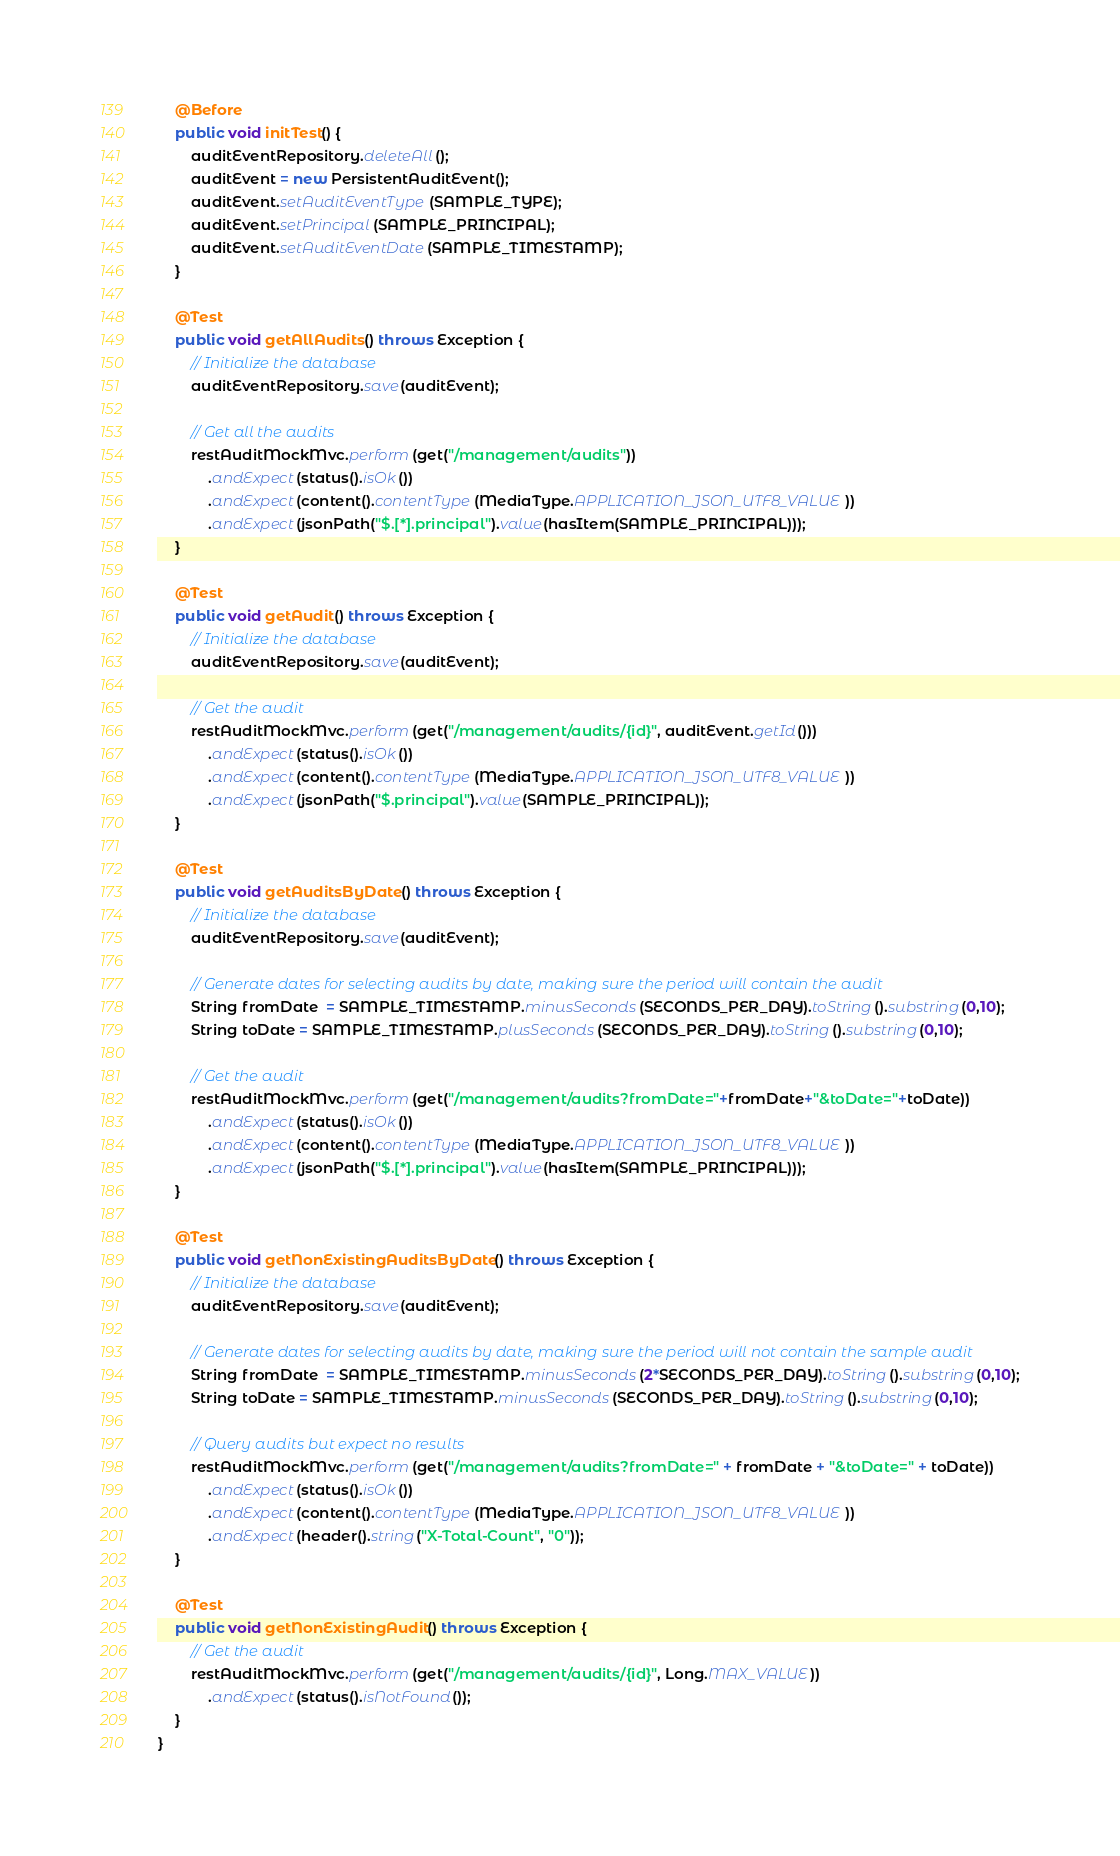Convert code to text. <code><loc_0><loc_0><loc_500><loc_500><_Java_>    @Before
    public void initTest() {
        auditEventRepository.deleteAll();
        auditEvent = new PersistentAuditEvent();
        auditEvent.setAuditEventType(SAMPLE_TYPE);
        auditEvent.setPrincipal(SAMPLE_PRINCIPAL);
        auditEvent.setAuditEventDate(SAMPLE_TIMESTAMP);
    }

    @Test
    public void getAllAudits() throws Exception {
        // Initialize the database
        auditEventRepository.save(auditEvent);

        // Get all the audits
        restAuditMockMvc.perform(get("/management/audits"))
            .andExpect(status().isOk())
            .andExpect(content().contentType(MediaType.APPLICATION_JSON_UTF8_VALUE))
            .andExpect(jsonPath("$.[*].principal").value(hasItem(SAMPLE_PRINCIPAL)));
    }

    @Test
    public void getAudit() throws Exception {
        // Initialize the database
        auditEventRepository.save(auditEvent);

        // Get the audit
        restAuditMockMvc.perform(get("/management/audits/{id}", auditEvent.getId()))
            .andExpect(status().isOk())
            .andExpect(content().contentType(MediaType.APPLICATION_JSON_UTF8_VALUE))
            .andExpect(jsonPath("$.principal").value(SAMPLE_PRINCIPAL));
    }

    @Test
    public void getAuditsByDate() throws Exception {
        // Initialize the database
        auditEventRepository.save(auditEvent);

        // Generate dates for selecting audits by date, making sure the period will contain the audit
        String fromDate  = SAMPLE_TIMESTAMP.minusSeconds(SECONDS_PER_DAY).toString().substring(0,10);
        String toDate = SAMPLE_TIMESTAMP.plusSeconds(SECONDS_PER_DAY).toString().substring(0,10);

        // Get the audit
        restAuditMockMvc.perform(get("/management/audits?fromDate="+fromDate+"&toDate="+toDate))
            .andExpect(status().isOk())
            .andExpect(content().contentType(MediaType.APPLICATION_JSON_UTF8_VALUE))
            .andExpect(jsonPath("$.[*].principal").value(hasItem(SAMPLE_PRINCIPAL)));
    }

    @Test
    public void getNonExistingAuditsByDate() throws Exception {
        // Initialize the database
        auditEventRepository.save(auditEvent);

        // Generate dates for selecting audits by date, making sure the period will not contain the sample audit
        String fromDate  = SAMPLE_TIMESTAMP.minusSeconds(2*SECONDS_PER_DAY).toString().substring(0,10);
        String toDate = SAMPLE_TIMESTAMP.minusSeconds(SECONDS_PER_DAY).toString().substring(0,10);

        // Query audits but expect no results
        restAuditMockMvc.perform(get("/management/audits?fromDate=" + fromDate + "&toDate=" + toDate))
            .andExpect(status().isOk())
            .andExpect(content().contentType(MediaType.APPLICATION_JSON_UTF8_VALUE))
            .andExpect(header().string("X-Total-Count", "0"));
    }

    @Test
    public void getNonExistingAudit() throws Exception {
        // Get the audit
        restAuditMockMvc.perform(get("/management/audits/{id}", Long.MAX_VALUE))
            .andExpect(status().isNotFound());
    }
}
</code> 